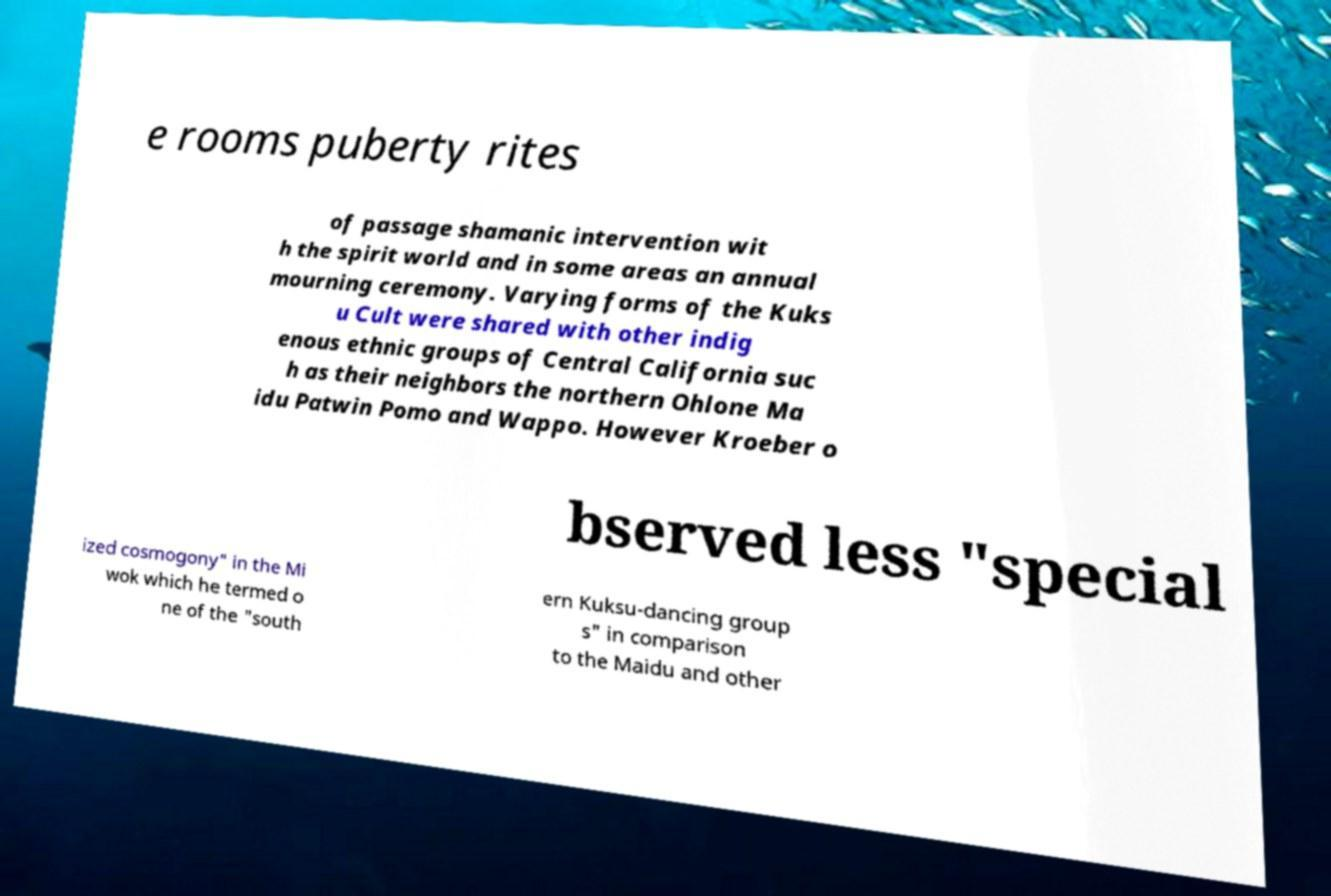What messages or text are displayed in this image? I need them in a readable, typed format. e rooms puberty rites of passage shamanic intervention wit h the spirit world and in some areas an annual mourning ceremony. Varying forms of the Kuks u Cult were shared with other indig enous ethnic groups of Central California suc h as their neighbors the northern Ohlone Ma idu Patwin Pomo and Wappo. However Kroeber o bserved less "special ized cosmogony" in the Mi wok which he termed o ne of the "south ern Kuksu-dancing group s" in comparison to the Maidu and other 